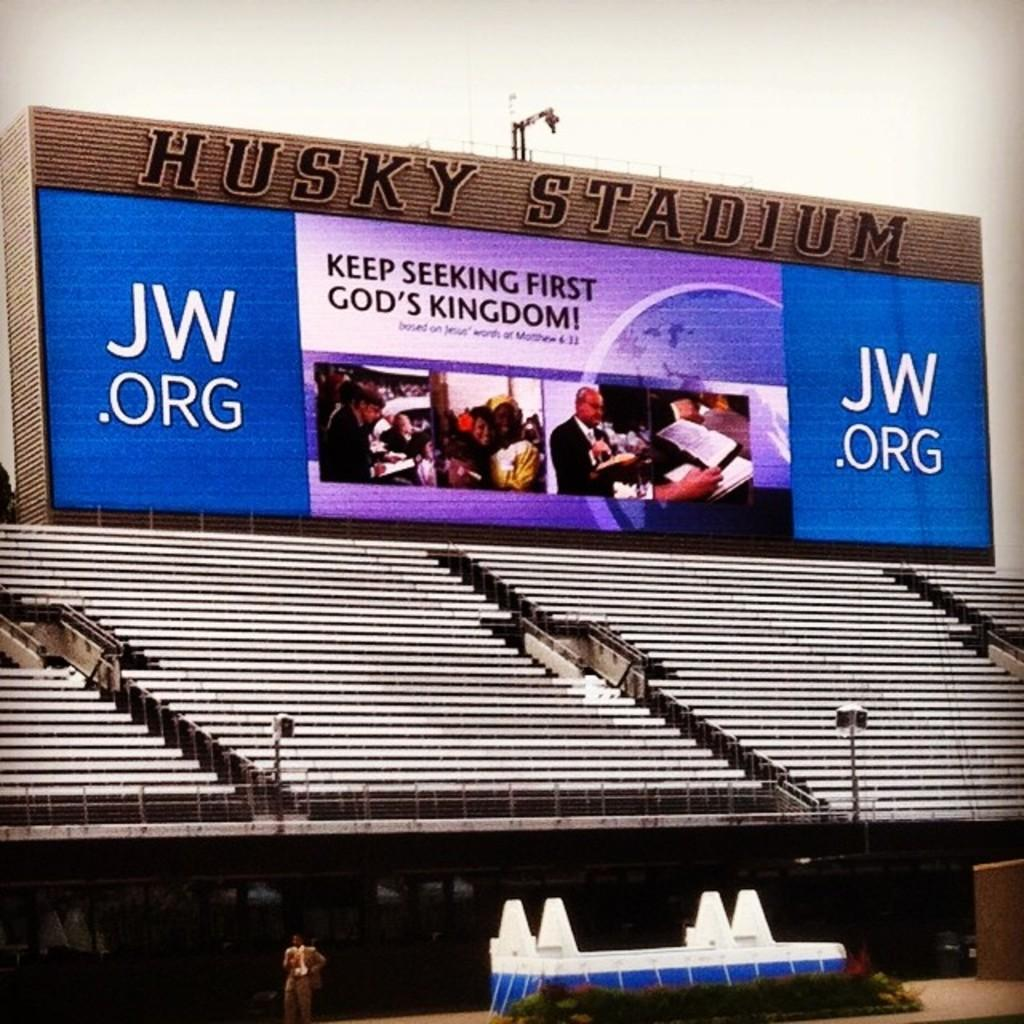Provide a one-sentence caption for the provided image. An advert for jw.org, a religious speaker, looms overan empty stand in a stadium. 